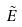Convert formula to latex. <formula><loc_0><loc_0><loc_500><loc_500>\tilde { E }</formula> 